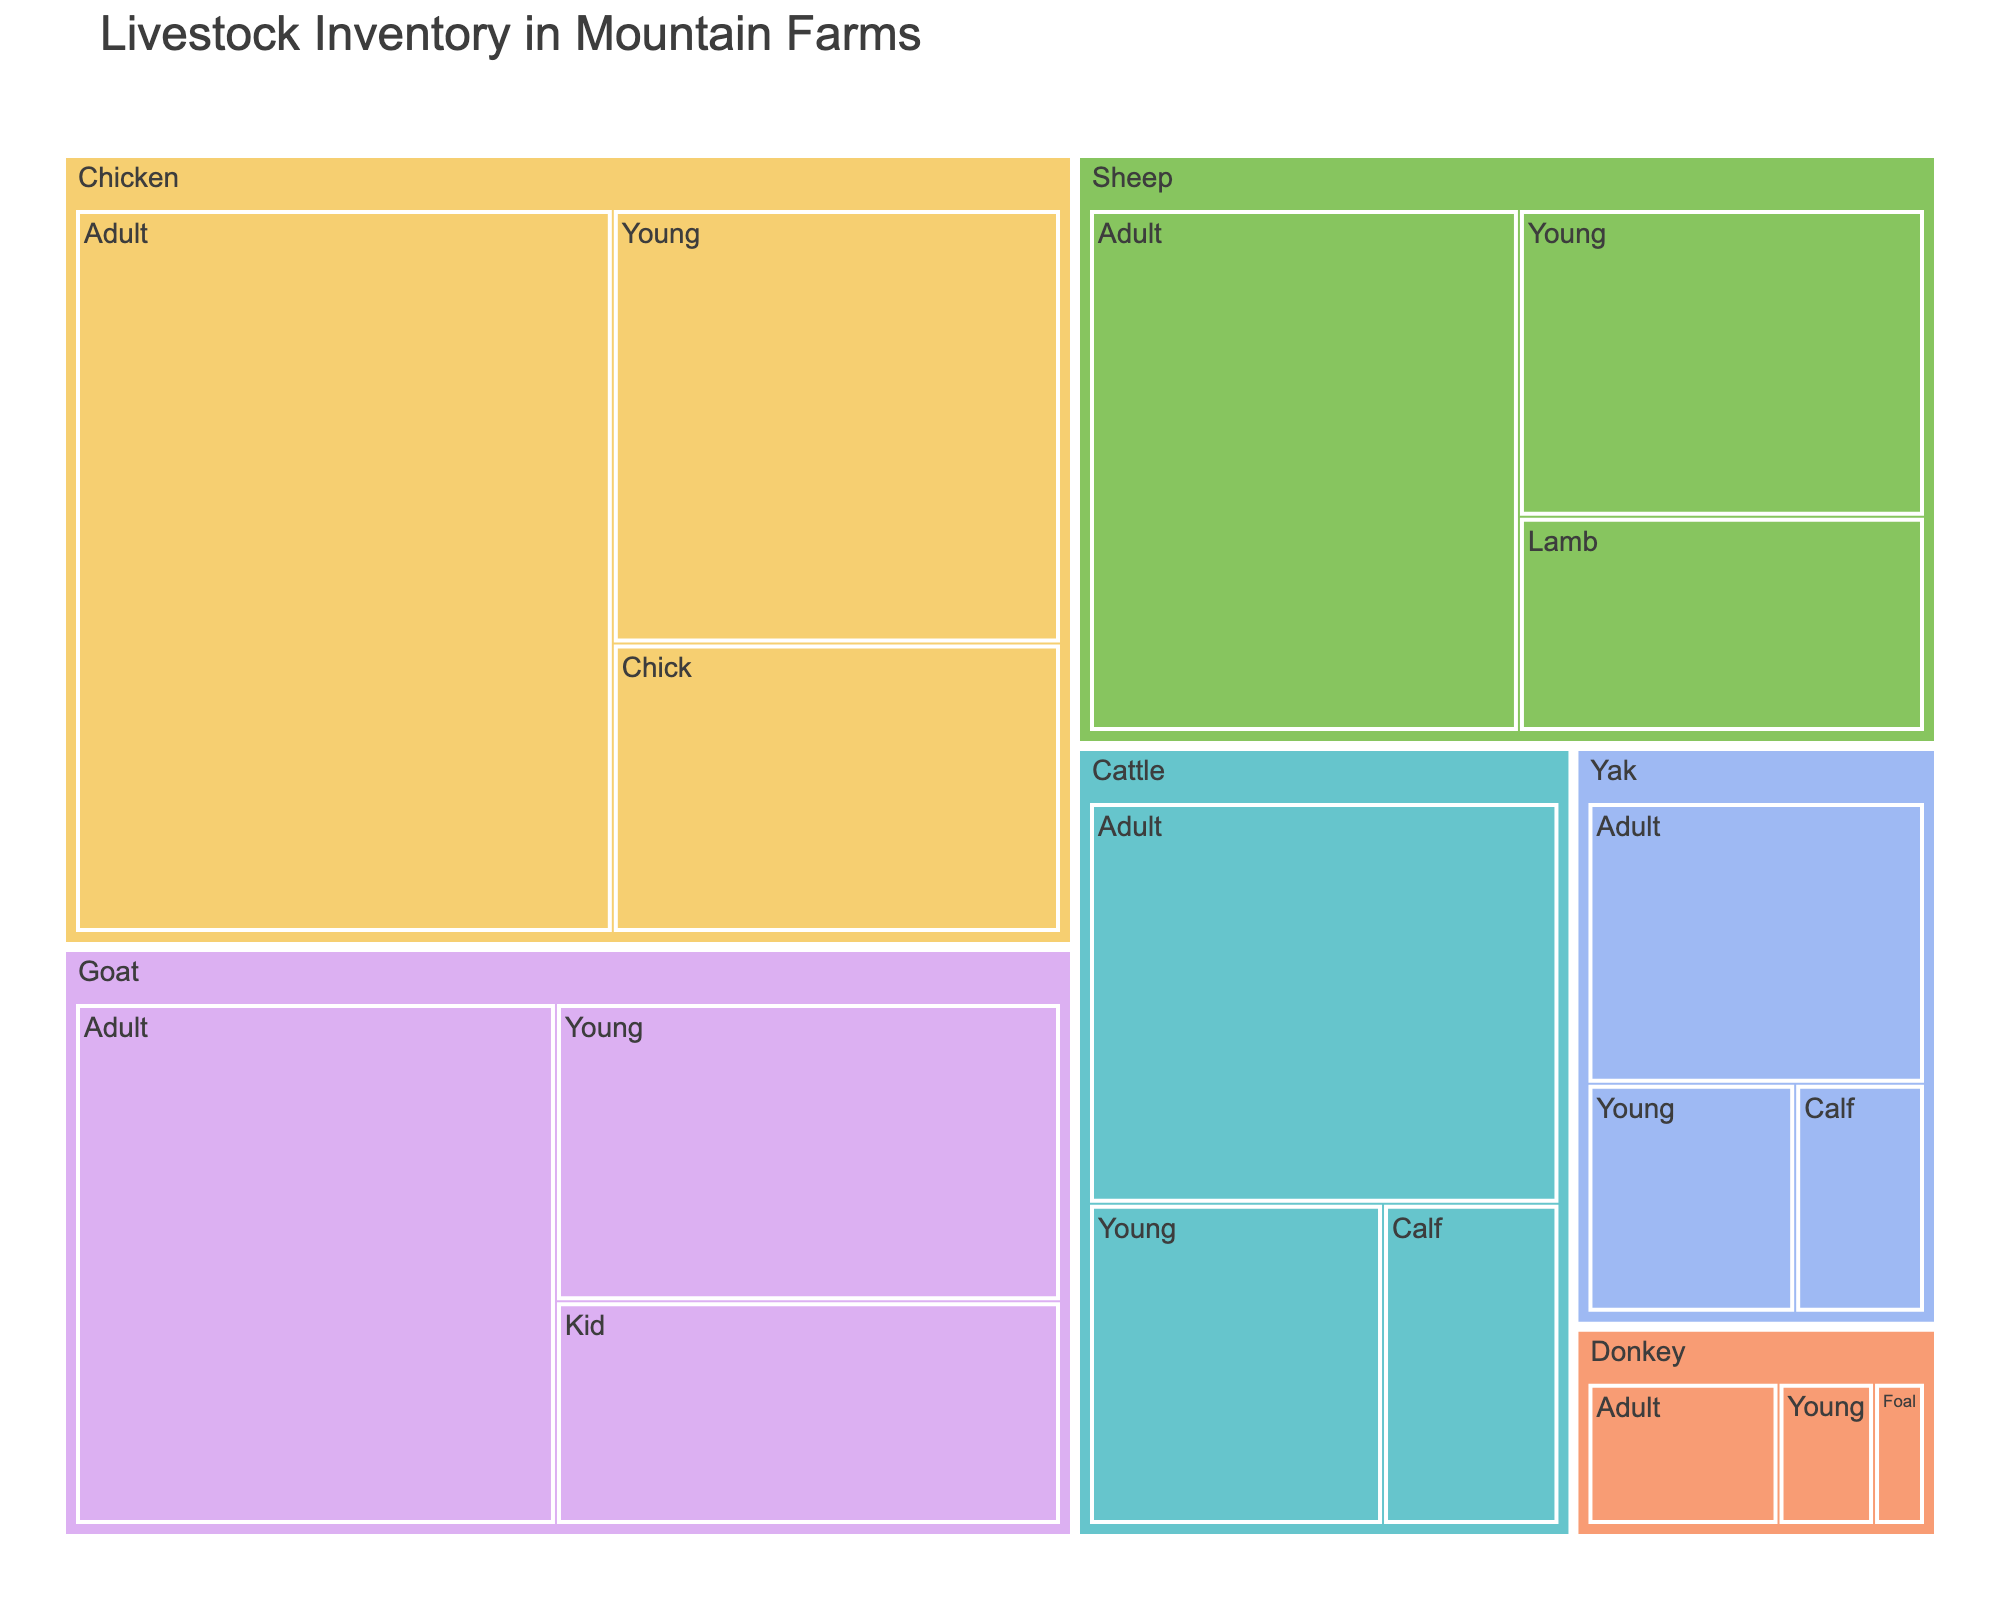What is the title of the treemap? The title of the treemap is typically displayed at the top of the figure.
Answer: Livestock Inventory in Mountain Farms How many species are displayed in the treemap? The treemap divides the inventory into different species, each clearly labeled. Count the number of distinct species.
Answer: 6 Which species has the highest total count? The size of each species' block in the treemap represents its total count. The largest block indicates the species with the highest total count.
Answer: Chicken How many adult goats are there? Locate the section labeled 'Goat' and then find the 'Adult' subsection within it. The count will be displayed there.
Answer: 200 Which species has the least number of young animals? For each species, identify the count for the 'Young' age group, and compare the counts to find the smallest one.
Answer: Donkey Calculate the total count of all livestock in the treemap. Sum the counts of all age groups across all species to find the total.
Answer: 1608 Which age group has the highest total count across all species? Sum the counts of all age groups across species, and then compare these sums to find the highest one.
Answer: Adult Compare the number of young chickens to young yaks. Which is greater, and by how much? Locate the count for 'Young' chickens and 'Young' yaks, then subtract the smaller count from the larger one to determine the difference.
Answer: Chickens by 110 Which species shows a more balanced distribution in ages? Assess the differences between age group counts within each species to determine which species has less variance.
Answer: Cattle What is the combined count of all yak and sheep calves? Locate the counts for 'Calf' within each species and sum them up. For sheep, identify and sum the corresponding 'Lamb' counts.
Answer: 95 